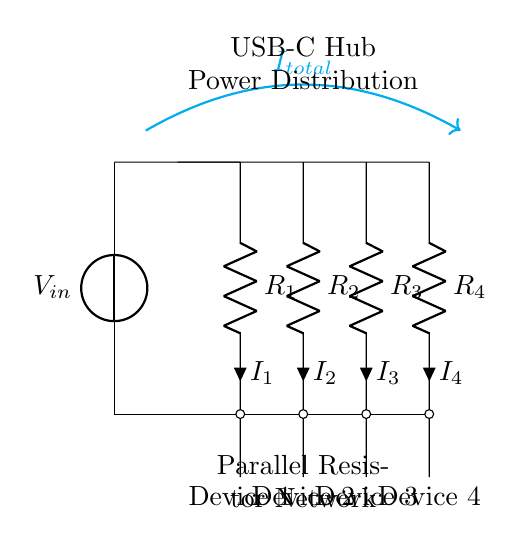What is the total current flowing into the circuit? The total current flowing into the circuit is denoted by \(I_{total}\) and is indicated by an arrow pointing into the circuit from the voltage source.
Answer: I total What is the function of the resistors in this diagram? The resistors in this diagram function as parallel components, dividing the current into separate paths for the devices connected to them.
Answer: Current division How many devices are connected to this power distribution network? There are four devices connected to the power distribution network, with each device represented by a resistor in the circuit.
Answer: Four What is the voltage at the input of the circuit? The voltage at the input of the circuit is labeled as \(V_{in}\), indicating the potential supplied by the USB-C source.
Answer: V in Which resistor will have the highest current if they are of equal value? If all resistors are of equal value, the current is equally divided among all resistors, thus none will have a higher current than the others.
Answer: None If \(R_1\) has a resistance of 2 ohms and \(R_2\) has a resistance of 4 ohms, which one has the higher voltage across it? In a parallel circuit, the voltage across all resistors is the same; hence the voltage across \(R_1\) and \(R_2\) will be equal.
Answer: Same voltage What type of circuit is this configuration an example of? This configuration is an example of a current divider circuit due to its parallel arrangement of resistors.
Answer: Current divider 